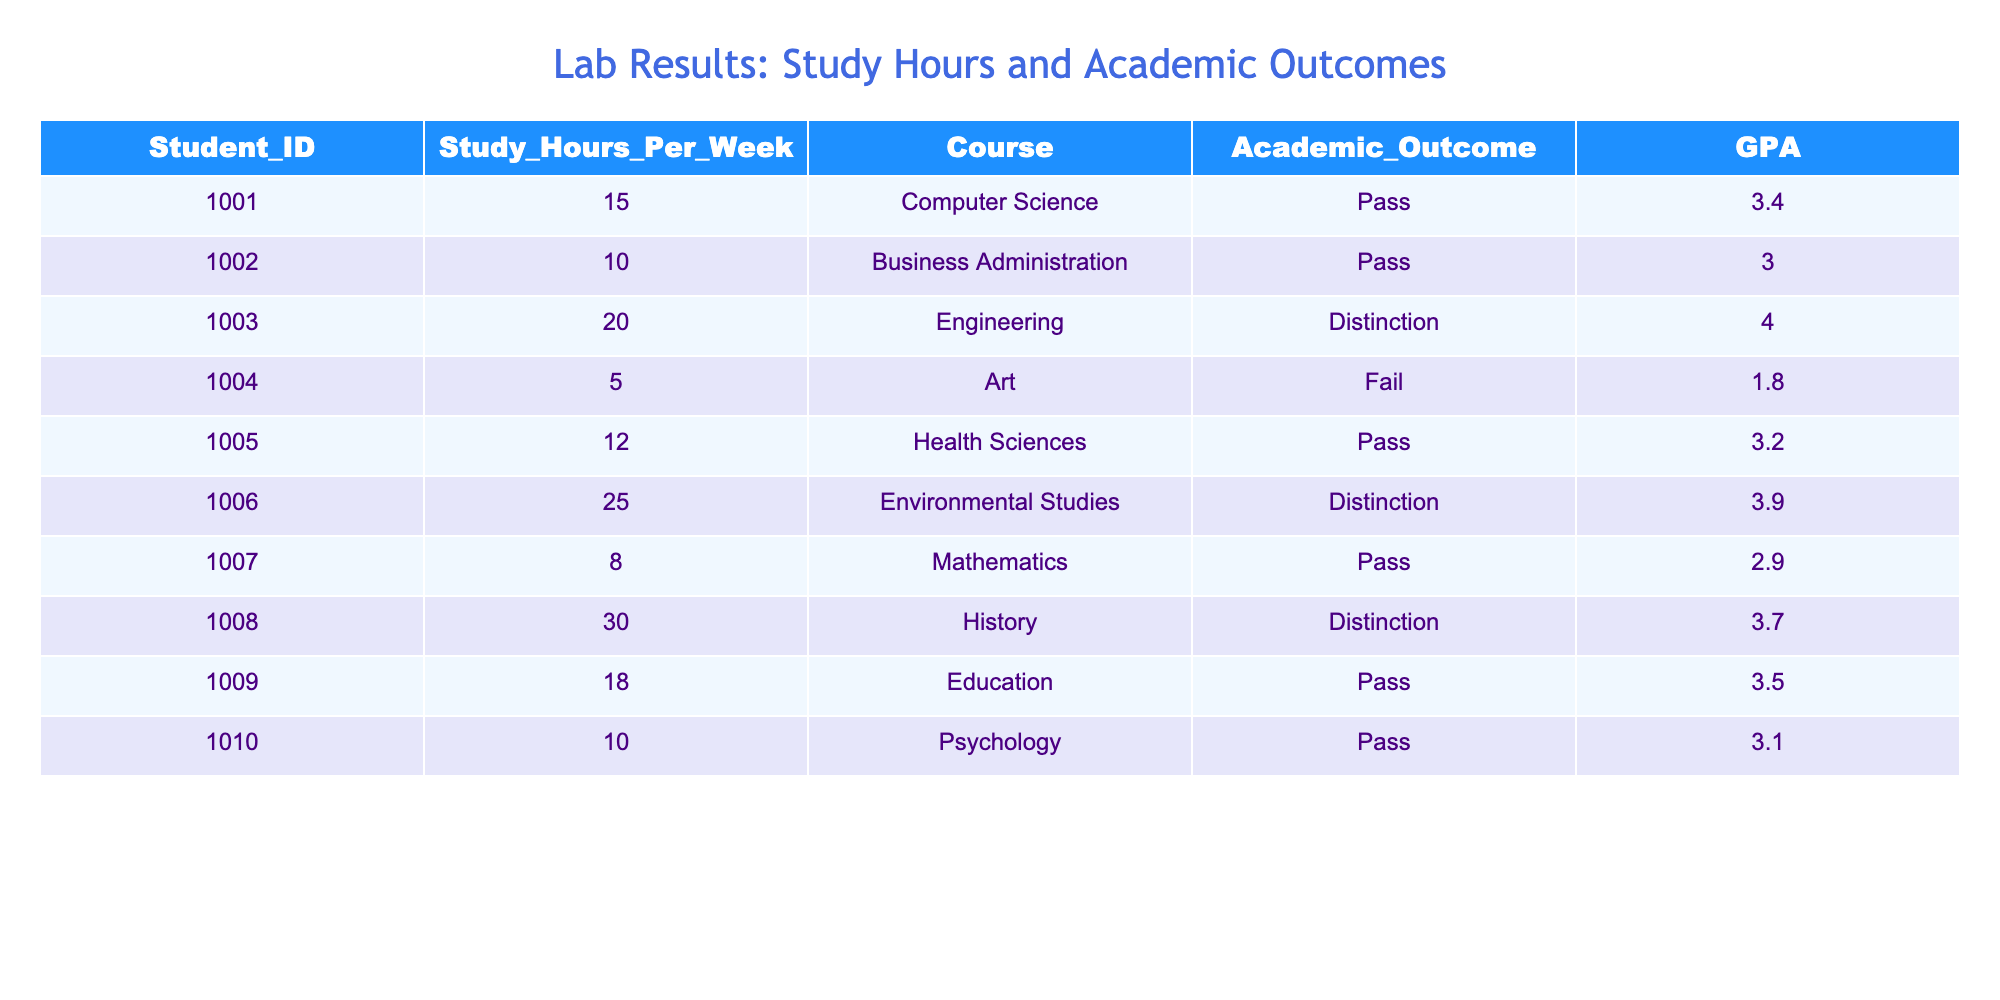What is the GPA of the student studying Environmental Studies? The student's ID is 1006, and the GPA associated with Environmental Studies in the table is 3.9
Answer: 3.9 How many study hours per week does the student with the highest GPA spend studying? The student with the highest GPA is in Engineering (ID 1003) with a GPA of 4.0, and their study hours per week are 20
Answer: 20 Is there any student who failed their course? Yes, the student with ID 1004 failed their course, as indicated in the Academic Outcome column
Answer: Yes What is the average GPA of students who passed their courses? The GPAs of those who passed are 3.4, 3.0, 3.2, 3.5, and 3.1. To find the average, sum these values (3.4 + 3.0 + 3.2 + 3.5 + 3.1 = 16.2) and divide by the total number of students who passed (5), resulting in an average of 16.2/5 = 3.24
Answer: 3.24 How many students studied more than 15 hours per week and achieved a distinction? The students who studied more than 15 hours are listed with IDs 1003, 1006, and 1008. Out of these, IDs 1003 (Distinction in Engineering) and 1006 (Distinction in Environmental Studies) achieved a distinction. Therefore, there are 2 such students
Answer: 2 Which course had the lowest GPA? The lowest GPA in the table is 1.8, which belongs to the student studying Art (ID 1004)
Answer: Art What is the difference in study hours between the student who studied the most and the one who studied the least? The student with the most study hours is ID 1008 with 30 hours and the one with the least is ID 1004 with 5 hours. The difference is calculated as 30 - 5 = 25
Answer: 25 Did any student who studied less than 10 hours pass their course? Yes, the student with ID 1007 studied 8 hours and passed their course, as shown in the table
Answer: Yes 